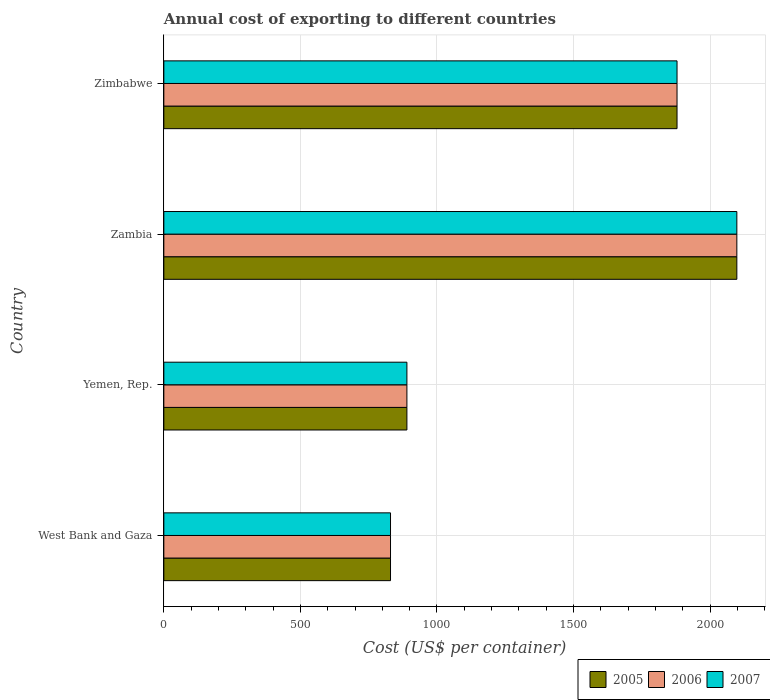Are the number of bars per tick equal to the number of legend labels?
Give a very brief answer. Yes. Are the number of bars on each tick of the Y-axis equal?
Offer a very short reply. Yes. How many bars are there on the 1st tick from the top?
Provide a short and direct response. 3. How many bars are there on the 3rd tick from the bottom?
Ensure brevity in your answer.  3. What is the label of the 2nd group of bars from the top?
Your response must be concise. Zambia. In how many cases, is the number of bars for a given country not equal to the number of legend labels?
Your answer should be compact. 0. What is the total annual cost of exporting in 2006 in Zimbabwe?
Your answer should be very brief. 1879. Across all countries, what is the maximum total annual cost of exporting in 2005?
Your answer should be very brief. 2098. Across all countries, what is the minimum total annual cost of exporting in 2005?
Your answer should be very brief. 830. In which country was the total annual cost of exporting in 2005 maximum?
Your answer should be compact. Zambia. In which country was the total annual cost of exporting in 2007 minimum?
Give a very brief answer. West Bank and Gaza. What is the total total annual cost of exporting in 2006 in the graph?
Ensure brevity in your answer.  5697. What is the difference between the total annual cost of exporting in 2007 in West Bank and Gaza and that in Yemen, Rep.?
Ensure brevity in your answer.  -60. What is the difference between the total annual cost of exporting in 2005 in Zimbabwe and the total annual cost of exporting in 2007 in West Bank and Gaza?
Ensure brevity in your answer.  1049. What is the average total annual cost of exporting in 2007 per country?
Offer a terse response. 1424.25. What is the difference between the total annual cost of exporting in 2007 and total annual cost of exporting in 2005 in Zimbabwe?
Offer a terse response. 0. What is the ratio of the total annual cost of exporting in 2005 in West Bank and Gaza to that in Zimbabwe?
Provide a succinct answer. 0.44. Is the total annual cost of exporting in 2005 in West Bank and Gaza less than that in Zambia?
Make the answer very short. Yes. What is the difference between the highest and the second highest total annual cost of exporting in 2005?
Your answer should be compact. 219. What is the difference between the highest and the lowest total annual cost of exporting in 2007?
Your response must be concise. 1268. In how many countries, is the total annual cost of exporting in 2006 greater than the average total annual cost of exporting in 2006 taken over all countries?
Your answer should be very brief. 2. What does the 2nd bar from the bottom in West Bank and Gaza represents?
Your answer should be compact. 2006. How many countries are there in the graph?
Provide a short and direct response. 4. Does the graph contain any zero values?
Keep it short and to the point. No. Does the graph contain grids?
Keep it short and to the point. Yes. What is the title of the graph?
Offer a very short reply. Annual cost of exporting to different countries. What is the label or title of the X-axis?
Give a very brief answer. Cost (US$ per container). What is the label or title of the Y-axis?
Your answer should be very brief. Country. What is the Cost (US$ per container) of 2005 in West Bank and Gaza?
Your answer should be compact. 830. What is the Cost (US$ per container) of 2006 in West Bank and Gaza?
Give a very brief answer. 830. What is the Cost (US$ per container) of 2007 in West Bank and Gaza?
Your answer should be compact. 830. What is the Cost (US$ per container) in 2005 in Yemen, Rep.?
Your answer should be very brief. 890. What is the Cost (US$ per container) of 2006 in Yemen, Rep.?
Your answer should be compact. 890. What is the Cost (US$ per container) in 2007 in Yemen, Rep.?
Provide a succinct answer. 890. What is the Cost (US$ per container) of 2005 in Zambia?
Give a very brief answer. 2098. What is the Cost (US$ per container) of 2006 in Zambia?
Your response must be concise. 2098. What is the Cost (US$ per container) in 2007 in Zambia?
Provide a succinct answer. 2098. What is the Cost (US$ per container) of 2005 in Zimbabwe?
Your response must be concise. 1879. What is the Cost (US$ per container) in 2006 in Zimbabwe?
Keep it short and to the point. 1879. What is the Cost (US$ per container) in 2007 in Zimbabwe?
Give a very brief answer. 1879. Across all countries, what is the maximum Cost (US$ per container) of 2005?
Give a very brief answer. 2098. Across all countries, what is the maximum Cost (US$ per container) in 2006?
Make the answer very short. 2098. Across all countries, what is the maximum Cost (US$ per container) in 2007?
Ensure brevity in your answer.  2098. Across all countries, what is the minimum Cost (US$ per container) of 2005?
Make the answer very short. 830. Across all countries, what is the minimum Cost (US$ per container) of 2006?
Provide a short and direct response. 830. Across all countries, what is the minimum Cost (US$ per container) in 2007?
Keep it short and to the point. 830. What is the total Cost (US$ per container) in 2005 in the graph?
Make the answer very short. 5697. What is the total Cost (US$ per container) of 2006 in the graph?
Offer a terse response. 5697. What is the total Cost (US$ per container) of 2007 in the graph?
Ensure brevity in your answer.  5697. What is the difference between the Cost (US$ per container) of 2005 in West Bank and Gaza and that in Yemen, Rep.?
Provide a succinct answer. -60. What is the difference between the Cost (US$ per container) in 2006 in West Bank and Gaza and that in Yemen, Rep.?
Ensure brevity in your answer.  -60. What is the difference between the Cost (US$ per container) of 2007 in West Bank and Gaza and that in Yemen, Rep.?
Give a very brief answer. -60. What is the difference between the Cost (US$ per container) of 2005 in West Bank and Gaza and that in Zambia?
Give a very brief answer. -1268. What is the difference between the Cost (US$ per container) of 2006 in West Bank and Gaza and that in Zambia?
Offer a terse response. -1268. What is the difference between the Cost (US$ per container) in 2007 in West Bank and Gaza and that in Zambia?
Offer a very short reply. -1268. What is the difference between the Cost (US$ per container) of 2005 in West Bank and Gaza and that in Zimbabwe?
Your answer should be compact. -1049. What is the difference between the Cost (US$ per container) of 2006 in West Bank and Gaza and that in Zimbabwe?
Make the answer very short. -1049. What is the difference between the Cost (US$ per container) of 2007 in West Bank and Gaza and that in Zimbabwe?
Make the answer very short. -1049. What is the difference between the Cost (US$ per container) of 2005 in Yemen, Rep. and that in Zambia?
Make the answer very short. -1208. What is the difference between the Cost (US$ per container) in 2006 in Yemen, Rep. and that in Zambia?
Give a very brief answer. -1208. What is the difference between the Cost (US$ per container) of 2007 in Yemen, Rep. and that in Zambia?
Make the answer very short. -1208. What is the difference between the Cost (US$ per container) in 2005 in Yemen, Rep. and that in Zimbabwe?
Offer a terse response. -989. What is the difference between the Cost (US$ per container) of 2006 in Yemen, Rep. and that in Zimbabwe?
Keep it short and to the point. -989. What is the difference between the Cost (US$ per container) in 2007 in Yemen, Rep. and that in Zimbabwe?
Provide a short and direct response. -989. What is the difference between the Cost (US$ per container) in 2005 in Zambia and that in Zimbabwe?
Offer a terse response. 219. What is the difference between the Cost (US$ per container) of 2006 in Zambia and that in Zimbabwe?
Your response must be concise. 219. What is the difference between the Cost (US$ per container) in 2007 in Zambia and that in Zimbabwe?
Your response must be concise. 219. What is the difference between the Cost (US$ per container) of 2005 in West Bank and Gaza and the Cost (US$ per container) of 2006 in Yemen, Rep.?
Keep it short and to the point. -60. What is the difference between the Cost (US$ per container) of 2005 in West Bank and Gaza and the Cost (US$ per container) of 2007 in Yemen, Rep.?
Provide a succinct answer. -60. What is the difference between the Cost (US$ per container) in 2006 in West Bank and Gaza and the Cost (US$ per container) in 2007 in Yemen, Rep.?
Offer a very short reply. -60. What is the difference between the Cost (US$ per container) of 2005 in West Bank and Gaza and the Cost (US$ per container) of 2006 in Zambia?
Provide a succinct answer. -1268. What is the difference between the Cost (US$ per container) in 2005 in West Bank and Gaza and the Cost (US$ per container) in 2007 in Zambia?
Your answer should be compact. -1268. What is the difference between the Cost (US$ per container) in 2006 in West Bank and Gaza and the Cost (US$ per container) in 2007 in Zambia?
Make the answer very short. -1268. What is the difference between the Cost (US$ per container) of 2005 in West Bank and Gaza and the Cost (US$ per container) of 2006 in Zimbabwe?
Your answer should be very brief. -1049. What is the difference between the Cost (US$ per container) of 2005 in West Bank and Gaza and the Cost (US$ per container) of 2007 in Zimbabwe?
Offer a terse response. -1049. What is the difference between the Cost (US$ per container) of 2006 in West Bank and Gaza and the Cost (US$ per container) of 2007 in Zimbabwe?
Ensure brevity in your answer.  -1049. What is the difference between the Cost (US$ per container) in 2005 in Yemen, Rep. and the Cost (US$ per container) in 2006 in Zambia?
Offer a very short reply. -1208. What is the difference between the Cost (US$ per container) in 2005 in Yemen, Rep. and the Cost (US$ per container) in 2007 in Zambia?
Ensure brevity in your answer.  -1208. What is the difference between the Cost (US$ per container) of 2006 in Yemen, Rep. and the Cost (US$ per container) of 2007 in Zambia?
Provide a succinct answer. -1208. What is the difference between the Cost (US$ per container) of 2005 in Yemen, Rep. and the Cost (US$ per container) of 2006 in Zimbabwe?
Offer a terse response. -989. What is the difference between the Cost (US$ per container) in 2005 in Yemen, Rep. and the Cost (US$ per container) in 2007 in Zimbabwe?
Offer a terse response. -989. What is the difference between the Cost (US$ per container) in 2006 in Yemen, Rep. and the Cost (US$ per container) in 2007 in Zimbabwe?
Ensure brevity in your answer.  -989. What is the difference between the Cost (US$ per container) of 2005 in Zambia and the Cost (US$ per container) of 2006 in Zimbabwe?
Keep it short and to the point. 219. What is the difference between the Cost (US$ per container) in 2005 in Zambia and the Cost (US$ per container) in 2007 in Zimbabwe?
Give a very brief answer. 219. What is the difference between the Cost (US$ per container) of 2006 in Zambia and the Cost (US$ per container) of 2007 in Zimbabwe?
Provide a succinct answer. 219. What is the average Cost (US$ per container) in 2005 per country?
Your answer should be compact. 1424.25. What is the average Cost (US$ per container) in 2006 per country?
Ensure brevity in your answer.  1424.25. What is the average Cost (US$ per container) in 2007 per country?
Your answer should be compact. 1424.25. What is the difference between the Cost (US$ per container) of 2005 and Cost (US$ per container) of 2007 in West Bank and Gaza?
Provide a short and direct response. 0. What is the difference between the Cost (US$ per container) of 2005 and Cost (US$ per container) of 2006 in Yemen, Rep.?
Make the answer very short. 0. What is the difference between the Cost (US$ per container) in 2005 and Cost (US$ per container) in 2007 in Yemen, Rep.?
Your response must be concise. 0. What is the difference between the Cost (US$ per container) in 2005 and Cost (US$ per container) in 2006 in Zambia?
Ensure brevity in your answer.  0. What is the difference between the Cost (US$ per container) of 2005 and Cost (US$ per container) of 2007 in Zambia?
Make the answer very short. 0. What is the difference between the Cost (US$ per container) of 2006 and Cost (US$ per container) of 2007 in Zambia?
Offer a terse response. 0. What is the difference between the Cost (US$ per container) of 2005 and Cost (US$ per container) of 2006 in Zimbabwe?
Provide a succinct answer. 0. What is the difference between the Cost (US$ per container) in 2006 and Cost (US$ per container) in 2007 in Zimbabwe?
Make the answer very short. 0. What is the ratio of the Cost (US$ per container) of 2005 in West Bank and Gaza to that in Yemen, Rep.?
Provide a succinct answer. 0.93. What is the ratio of the Cost (US$ per container) in 2006 in West Bank and Gaza to that in Yemen, Rep.?
Keep it short and to the point. 0.93. What is the ratio of the Cost (US$ per container) in 2007 in West Bank and Gaza to that in Yemen, Rep.?
Keep it short and to the point. 0.93. What is the ratio of the Cost (US$ per container) of 2005 in West Bank and Gaza to that in Zambia?
Offer a terse response. 0.4. What is the ratio of the Cost (US$ per container) of 2006 in West Bank and Gaza to that in Zambia?
Give a very brief answer. 0.4. What is the ratio of the Cost (US$ per container) of 2007 in West Bank and Gaza to that in Zambia?
Offer a terse response. 0.4. What is the ratio of the Cost (US$ per container) in 2005 in West Bank and Gaza to that in Zimbabwe?
Your response must be concise. 0.44. What is the ratio of the Cost (US$ per container) of 2006 in West Bank and Gaza to that in Zimbabwe?
Give a very brief answer. 0.44. What is the ratio of the Cost (US$ per container) in 2007 in West Bank and Gaza to that in Zimbabwe?
Offer a very short reply. 0.44. What is the ratio of the Cost (US$ per container) in 2005 in Yemen, Rep. to that in Zambia?
Offer a very short reply. 0.42. What is the ratio of the Cost (US$ per container) of 2006 in Yemen, Rep. to that in Zambia?
Make the answer very short. 0.42. What is the ratio of the Cost (US$ per container) of 2007 in Yemen, Rep. to that in Zambia?
Provide a short and direct response. 0.42. What is the ratio of the Cost (US$ per container) of 2005 in Yemen, Rep. to that in Zimbabwe?
Your answer should be compact. 0.47. What is the ratio of the Cost (US$ per container) in 2006 in Yemen, Rep. to that in Zimbabwe?
Keep it short and to the point. 0.47. What is the ratio of the Cost (US$ per container) in 2007 in Yemen, Rep. to that in Zimbabwe?
Offer a terse response. 0.47. What is the ratio of the Cost (US$ per container) in 2005 in Zambia to that in Zimbabwe?
Provide a short and direct response. 1.12. What is the ratio of the Cost (US$ per container) of 2006 in Zambia to that in Zimbabwe?
Give a very brief answer. 1.12. What is the ratio of the Cost (US$ per container) of 2007 in Zambia to that in Zimbabwe?
Ensure brevity in your answer.  1.12. What is the difference between the highest and the second highest Cost (US$ per container) of 2005?
Your response must be concise. 219. What is the difference between the highest and the second highest Cost (US$ per container) of 2006?
Ensure brevity in your answer.  219. What is the difference between the highest and the second highest Cost (US$ per container) of 2007?
Make the answer very short. 219. What is the difference between the highest and the lowest Cost (US$ per container) in 2005?
Your answer should be very brief. 1268. What is the difference between the highest and the lowest Cost (US$ per container) in 2006?
Your answer should be very brief. 1268. What is the difference between the highest and the lowest Cost (US$ per container) in 2007?
Your answer should be compact. 1268. 